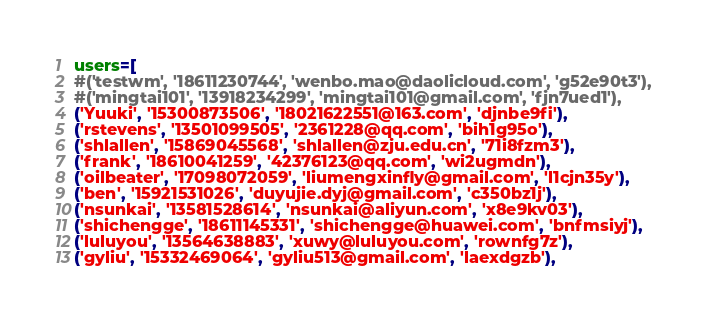Convert code to text. <code><loc_0><loc_0><loc_500><loc_500><_Python_>users=[
#('testwm', '18611230744', 'wenbo.mao@daolicloud.com', 'g52e90t3'),
#('mingtai101', '13918234299', 'mingtai101@gmail.com', 'fjn7ued1'),
('Yuuki', '15300873506', '18021622551@163.com', 'djnbe9fi'),
('rstevens', '13501099505', '2361228@qq.com', 'bih1g95o'),
('shlallen', '15869045568', 'shlallen@zju.edu.cn', '71i8fzm3'),
('frank', '18610041259', '42376123@qq.com', 'wi2ugmdn'),
('oilbeater', '17098072059', 'liumengxinfly@gmail.com', 'l1cjn35y'),
('ben', '15921531026', 'duyujie.dyj@gmail.com', 'c350bz1j'),
('nsunkai', '13581528614', 'nsunkai@aliyun.com', 'x8e9kv03'),
('shichengge', '18611145331', 'shichengge@huawei.com', 'bnfmsiyj'),
('luluyou', '13564638883', 'xuwy@luluyou.com', 'rownfg7z'),
('gyliu', '15332469064', 'gyliu513@gmail.com', 'laexdgzb'),</code> 